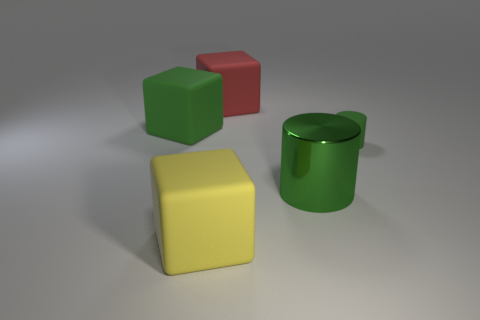Add 4 tiny objects. How many objects exist? 9 Subtract all cylinders. How many objects are left? 3 Add 5 green rubber cubes. How many green rubber cubes are left? 6 Add 3 small purple rubber spheres. How many small purple rubber spheres exist? 3 Subtract 0 purple cylinders. How many objects are left? 5 Subtract all blue things. Subtract all small green objects. How many objects are left? 4 